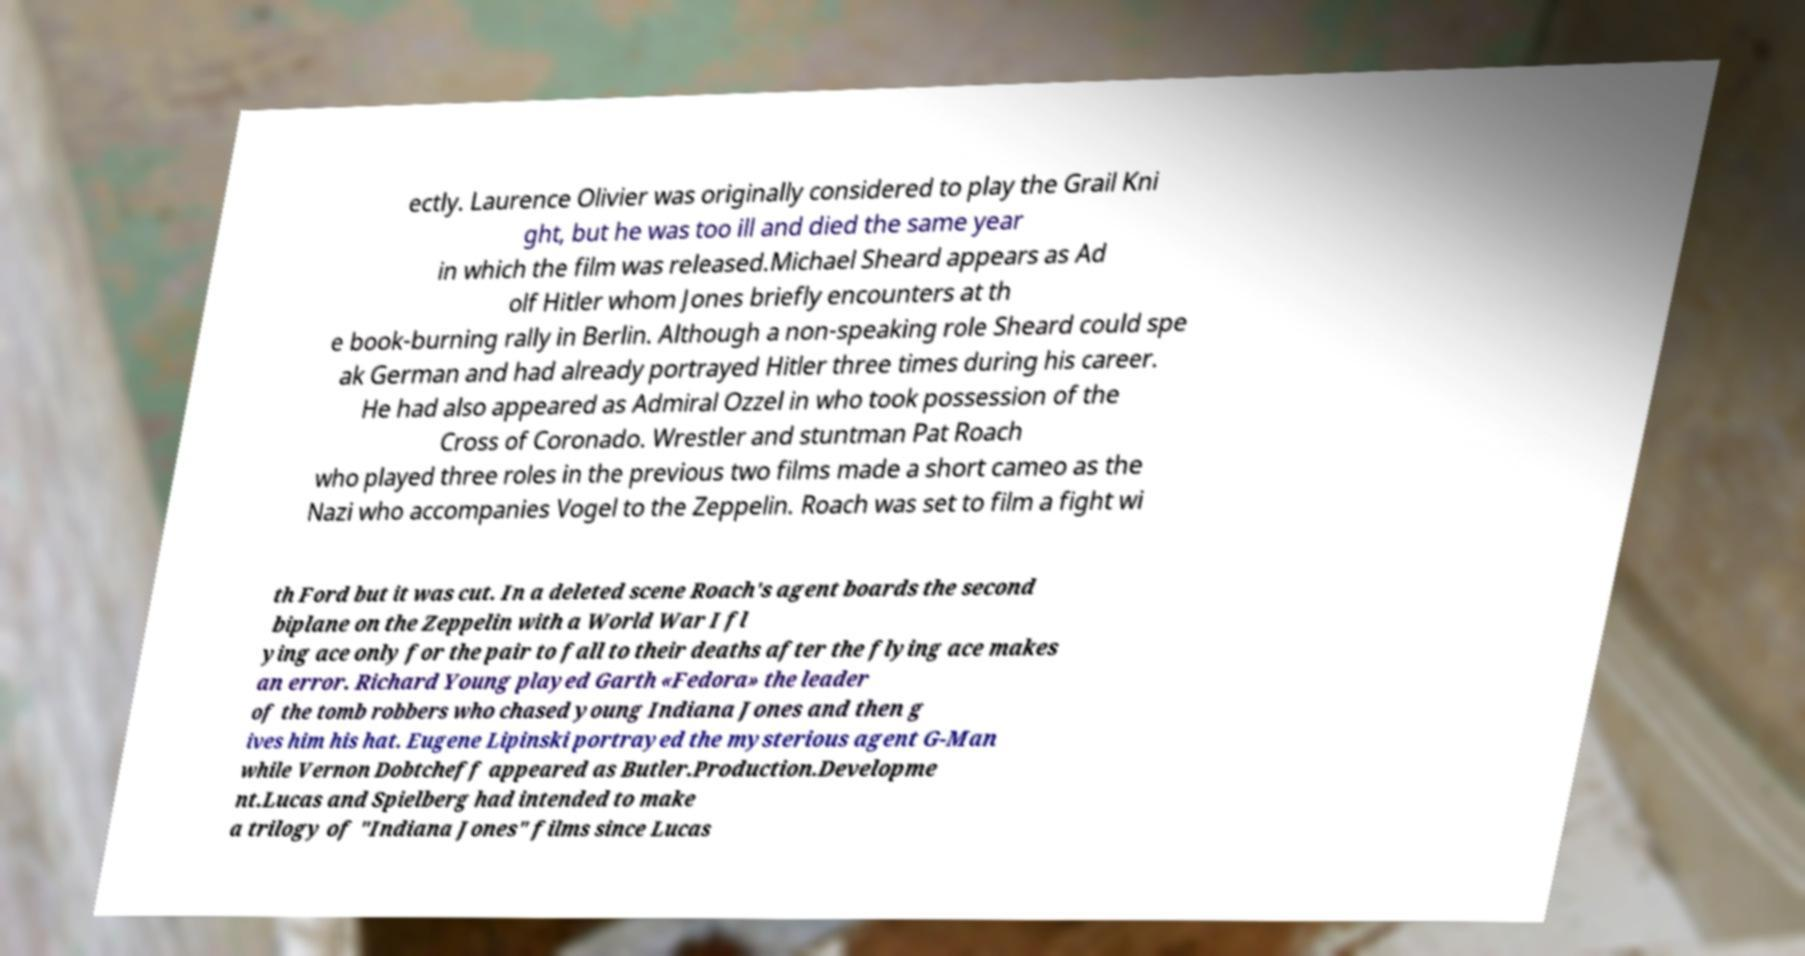There's text embedded in this image that I need extracted. Can you transcribe it verbatim? ectly. Laurence Olivier was originally considered to play the Grail Kni ght, but he was too ill and died the same year in which the film was released.Michael Sheard appears as Ad olf Hitler whom Jones briefly encounters at th e book-burning rally in Berlin. Although a non-speaking role Sheard could spe ak German and had already portrayed Hitler three times during his career. He had also appeared as Admiral Ozzel in who took possession of the Cross of Coronado. Wrestler and stuntman Pat Roach who played three roles in the previous two films made a short cameo as the Nazi who accompanies Vogel to the Zeppelin. Roach was set to film a fight wi th Ford but it was cut. In a deleted scene Roach's agent boards the second biplane on the Zeppelin with a World War I fl ying ace only for the pair to fall to their deaths after the flying ace makes an error. Richard Young played Garth «Fedora» the leader of the tomb robbers who chased young Indiana Jones and then g ives him his hat. Eugene Lipinski portrayed the mysterious agent G-Man while Vernon Dobtcheff appeared as Butler.Production.Developme nt.Lucas and Spielberg had intended to make a trilogy of "Indiana Jones" films since Lucas 